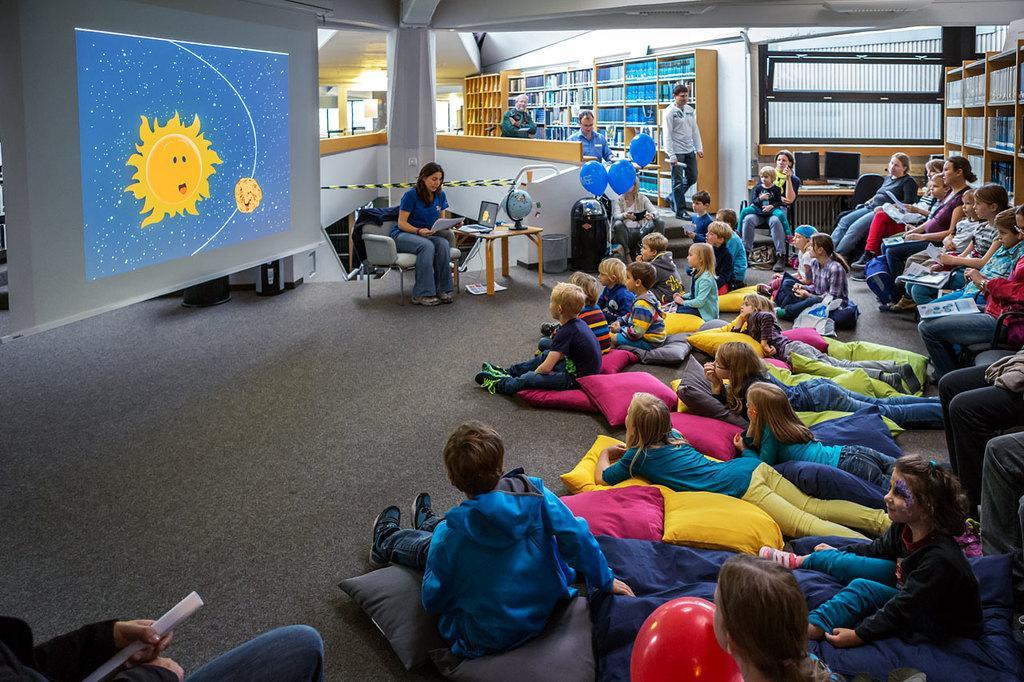Please provide a concise description of this image. In this picture we can see a group of people some are sitting on chairs some are standing and some are sleeping on floor and some are sitting on pillows and in background we can see pillars, rack, screen, tablet, laptop, globe. 